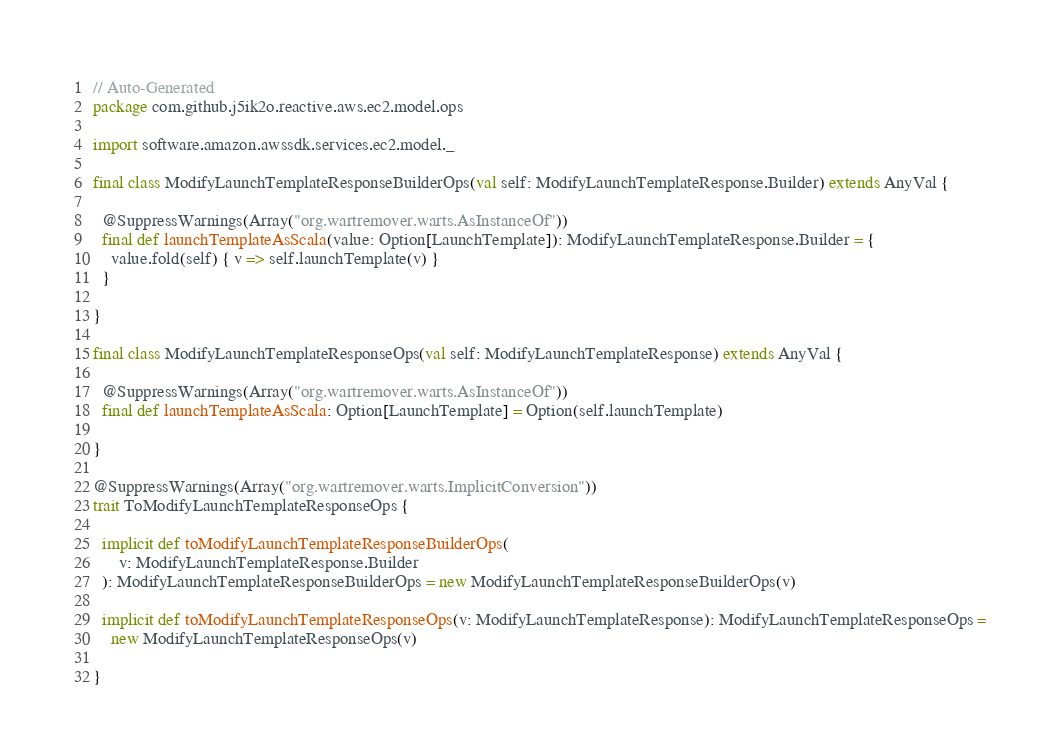Convert code to text. <code><loc_0><loc_0><loc_500><loc_500><_Scala_>// Auto-Generated
package com.github.j5ik2o.reactive.aws.ec2.model.ops

import software.amazon.awssdk.services.ec2.model._

final class ModifyLaunchTemplateResponseBuilderOps(val self: ModifyLaunchTemplateResponse.Builder) extends AnyVal {

  @SuppressWarnings(Array("org.wartremover.warts.AsInstanceOf"))
  final def launchTemplateAsScala(value: Option[LaunchTemplate]): ModifyLaunchTemplateResponse.Builder = {
    value.fold(self) { v => self.launchTemplate(v) }
  }

}

final class ModifyLaunchTemplateResponseOps(val self: ModifyLaunchTemplateResponse) extends AnyVal {

  @SuppressWarnings(Array("org.wartremover.warts.AsInstanceOf"))
  final def launchTemplateAsScala: Option[LaunchTemplate] = Option(self.launchTemplate)

}

@SuppressWarnings(Array("org.wartremover.warts.ImplicitConversion"))
trait ToModifyLaunchTemplateResponseOps {

  implicit def toModifyLaunchTemplateResponseBuilderOps(
      v: ModifyLaunchTemplateResponse.Builder
  ): ModifyLaunchTemplateResponseBuilderOps = new ModifyLaunchTemplateResponseBuilderOps(v)

  implicit def toModifyLaunchTemplateResponseOps(v: ModifyLaunchTemplateResponse): ModifyLaunchTemplateResponseOps =
    new ModifyLaunchTemplateResponseOps(v)

}
</code> 